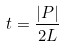<formula> <loc_0><loc_0><loc_500><loc_500>t = \frac { | P | } { 2 L }</formula> 